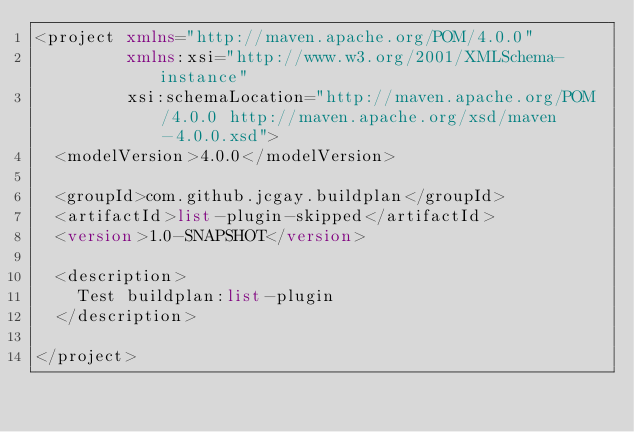Convert code to text. <code><loc_0><loc_0><loc_500><loc_500><_XML_><project xmlns="http://maven.apache.org/POM/4.0.0"
         xmlns:xsi="http://www.w3.org/2001/XMLSchema-instance"
         xsi:schemaLocation="http://maven.apache.org/POM/4.0.0 http://maven.apache.org/xsd/maven-4.0.0.xsd">
  <modelVersion>4.0.0</modelVersion>

  <groupId>com.github.jcgay.buildplan</groupId>
  <artifactId>list-plugin-skipped</artifactId>
  <version>1.0-SNAPSHOT</version>

  <description>
    Test buildplan:list-plugin
  </description>

</project>
</code> 